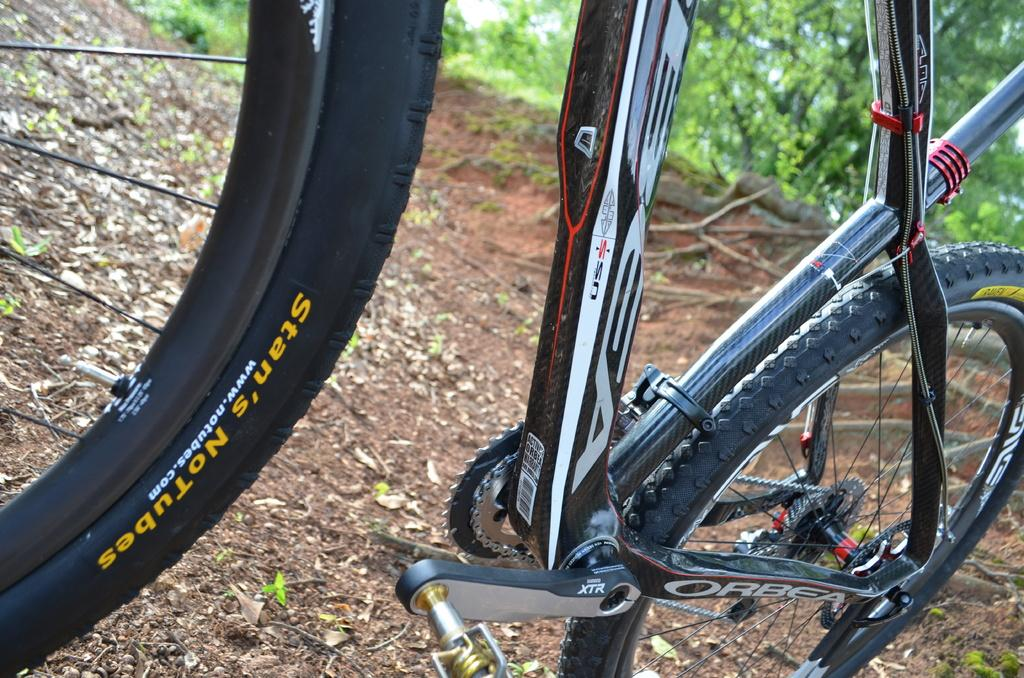What is the main object in the image? There is a bicycle in the image. What type of vegetation can be seen in the image? There are green trees in the image. What is present on the ground in the image? There are leaves on the ground in the image. What type of chair is depicted in the story in the image? There is no story or chair present in the image; it features a bicycle and green trees. How much quartz can be found in the image? There is no quartz present in the image. 